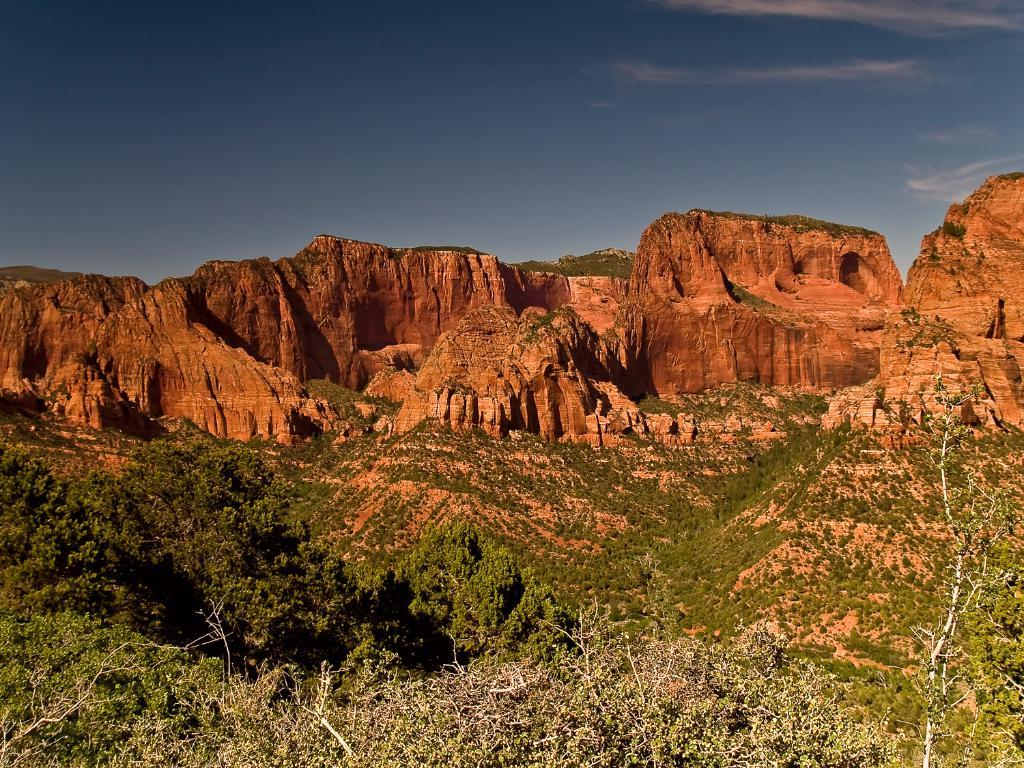What is the main feature in the center of the image? There are mountains in the center of the image. What type of vegetation can be seen at the bottom of the image? There is grass and trees at the bottom of the image. What is visible at the top of the image? The sky is visible at the top of the image. What type of pollution can be seen in the image? There is no pollution visible in the image; it features mountains, grass, trees, and the sky. Can you tell me how many pigs are present in the image? There are no pigs present in the image. 